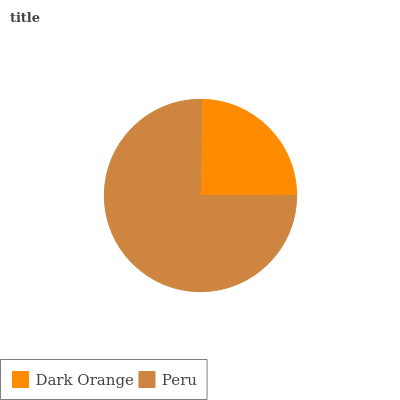Is Dark Orange the minimum?
Answer yes or no. Yes. Is Peru the maximum?
Answer yes or no. Yes. Is Peru the minimum?
Answer yes or no. No. Is Peru greater than Dark Orange?
Answer yes or no. Yes. Is Dark Orange less than Peru?
Answer yes or no. Yes. Is Dark Orange greater than Peru?
Answer yes or no. No. Is Peru less than Dark Orange?
Answer yes or no. No. Is Peru the high median?
Answer yes or no. Yes. Is Dark Orange the low median?
Answer yes or no. Yes. Is Dark Orange the high median?
Answer yes or no. No. Is Peru the low median?
Answer yes or no. No. 